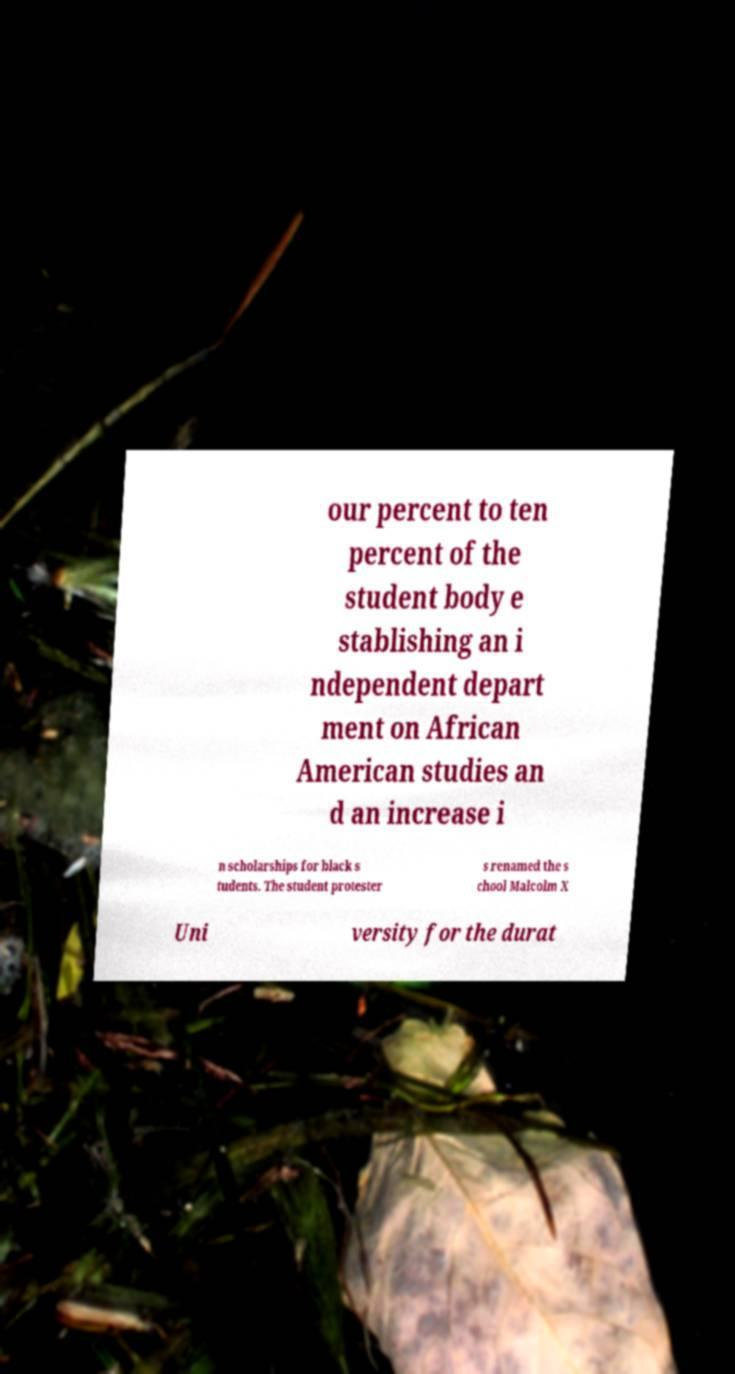Could you extract and type out the text from this image? our percent to ten percent of the student body e stablishing an i ndependent depart ment on African American studies an d an increase i n scholarships for black s tudents. The student protester s renamed the s chool Malcolm X Uni versity for the durat 